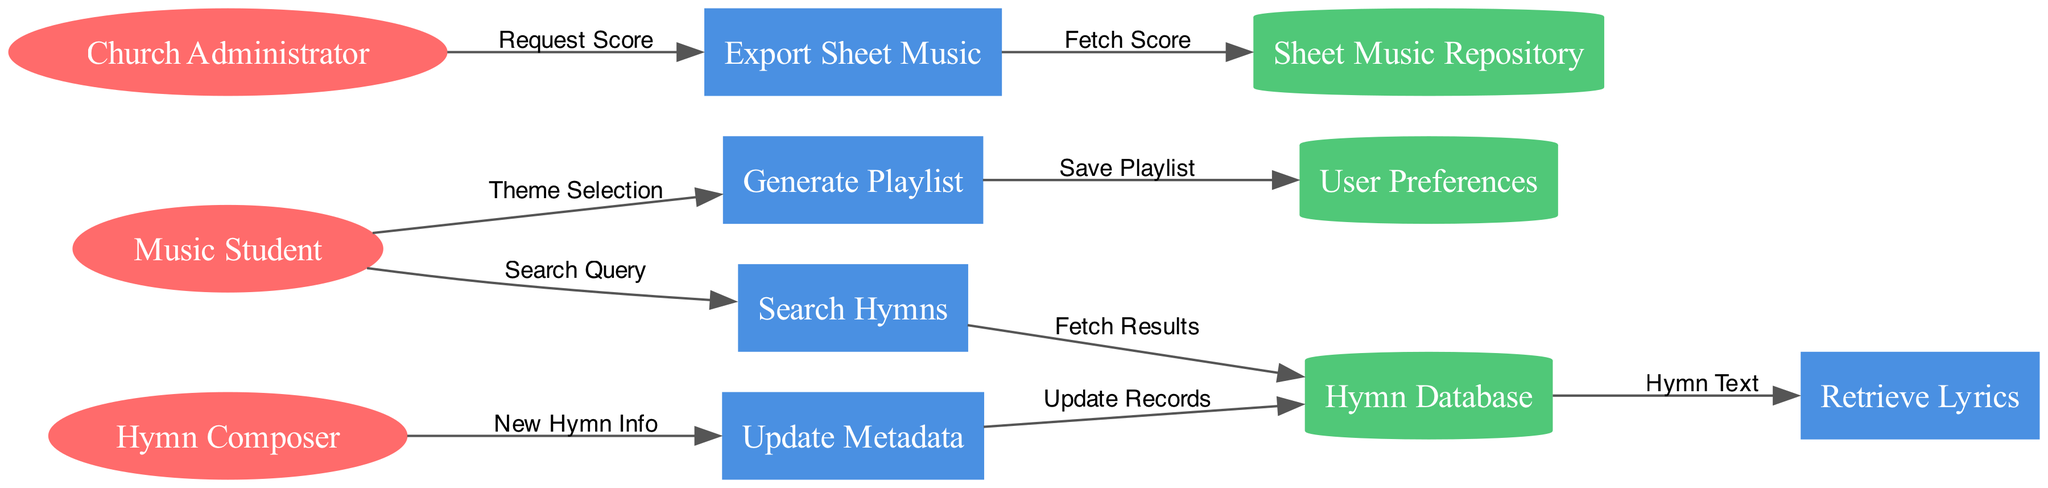What are the external entities in the diagram? The diagram includes three external entities: Music Student, Hymn Composer, and Church Administrator. They are represented as ellipses at the start of the data flow.
Answer: Music Student, Hymn Composer, Church Administrator How many processes are shown in the diagram? The diagram illustrates five processes: Search Hymns, Update Metadata, Generate Playlist, Retrieve Lyrics, and Export Sheet Music. They are represented as rectangles in the diagram.
Answer: Five Which process follows the Search Hymns process? After a search query is executed in the Search Hymns process, the next step is fetching results from the Hymn Database. This can be seen as a direct flow from the Search Hymns process to the Hymn Database.
Answer: Hymn Database What does the Church Administrator request from the Export Sheet Music process? The Church Administrator submits a Request Score to initiate the Export Sheet Music process. This flow is indicated by an arrow from the Church Administrator to Export Sheet Music.
Answer: Request Score From the Generate Playlist process, where does the data flow next? The Generate Playlist process sends data to the User Preferences storage to save the generated playlist. This is evident from the arrow indicating this data flow.
Answer: User Preferences How is new hymn information added to the Hymn Database? New hymn information is provided by the Hymn Composer to the Update Metadata process, which subsequently updates the records in the Hymn Database. This flow consists of two connections: one from the Hymn Composer to Update Metadata and another from Update Metadata to Hymn Database.
Answer: Update Records Which data flow represents the lyrics retrieval from the Hymn Database? The flow from the Hymn Database to the Retrieve Lyrics process represents the retrieval of hymn lyrics, specifically labeled Hymn Text. It shows the connection between these two processes regarding lyric access.
Answer: Hymn Text What type of data store is the Sheet Music Repository? The Sheet Music Repository is represented as a cylinder, indicating that it is a data storage location intended to hold sheet music, differentiated in style from processes and external entities.
Answer: Cylinder 